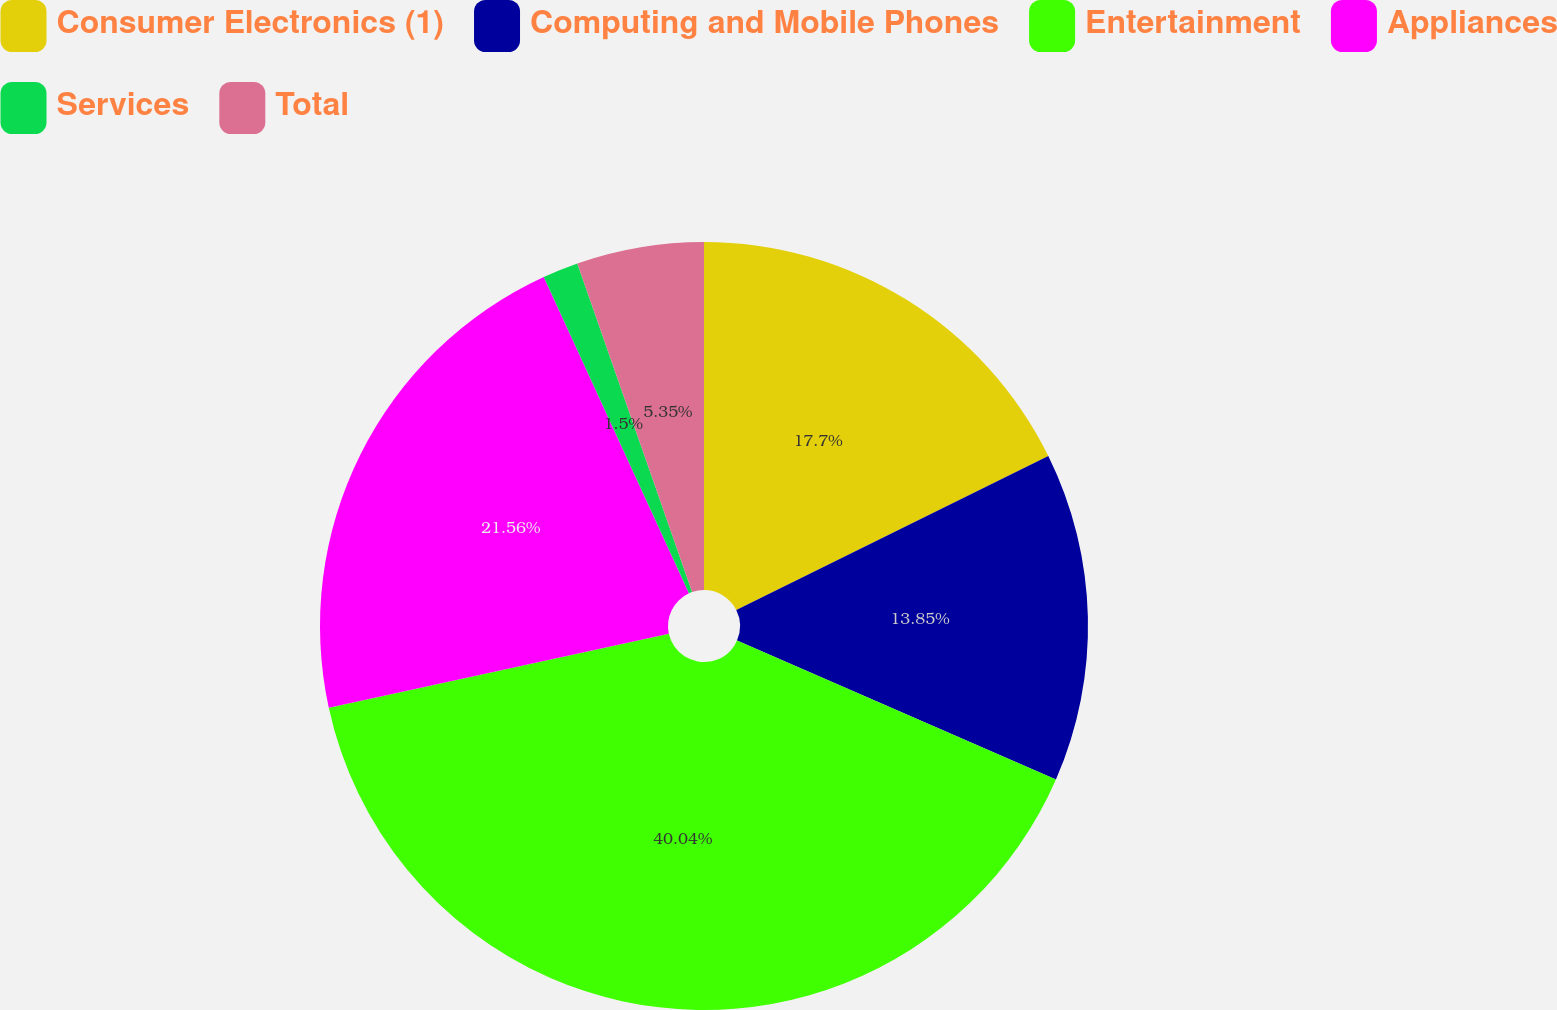<chart> <loc_0><loc_0><loc_500><loc_500><pie_chart><fcel>Consumer Electronics (1)<fcel>Computing and Mobile Phones<fcel>Entertainment<fcel>Appliances<fcel>Services<fcel>Total<nl><fcel>17.7%<fcel>13.85%<fcel>40.04%<fcel>21.56%<fcel>1.5%<fcel>5.35%<nl></chart> 